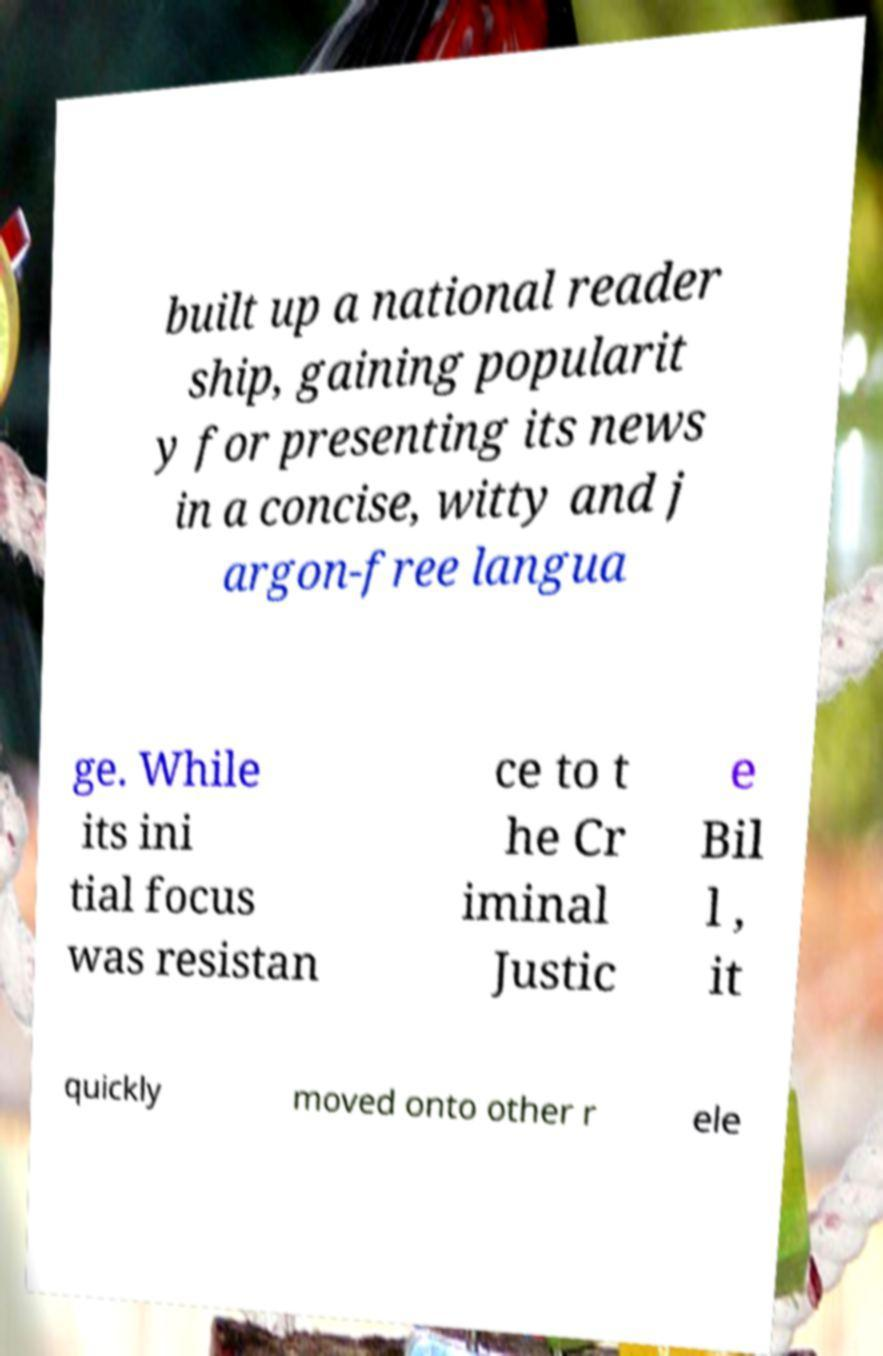There's text embedded in this image that I need extracted. Can you transcribe it verbatim? built up a national reader ship, gaining popularit y for presenting its news in a concise, witty and j argon-free langua ge. While its ini tial focus was resistan ce to t he Cr iminal Justic e Bil l , it quickly moved onto other r ele 